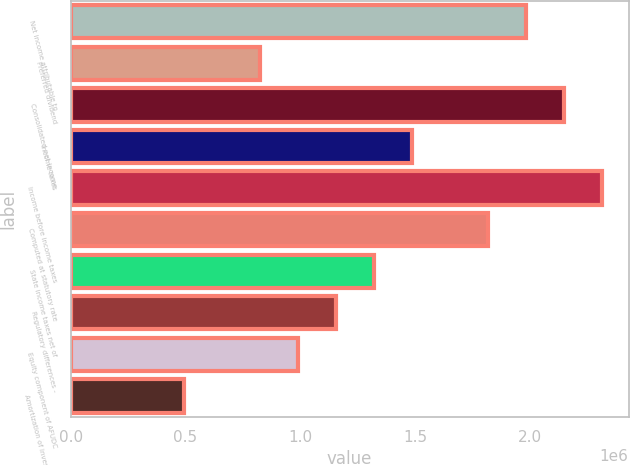<chart> <loc_0><loc_0><loc_500><loc_500><bar_chart><fcel>Net income attributable to<fcel>Preferred dividend<fcel>Consolidated net income<fcel>Income taxes<fcel>Income before income taxes<fcel>Computed at statutory rate<fcel>State income taxes net of<fcel>Regulatory differences -<fcel>Equity component of AFUDC<fcel>Amortization of investment tax<nl><fcel>1.98436e+06<fcel>826826<fcel>2.14972e+06<fcel>1.48827e+06<fcel>2.31508e+06<fcel>1.819e+06<fcel>1.32291e+06<fcel>1.15755e+06<fcel>992188<fcel>496103<nl></chart> 